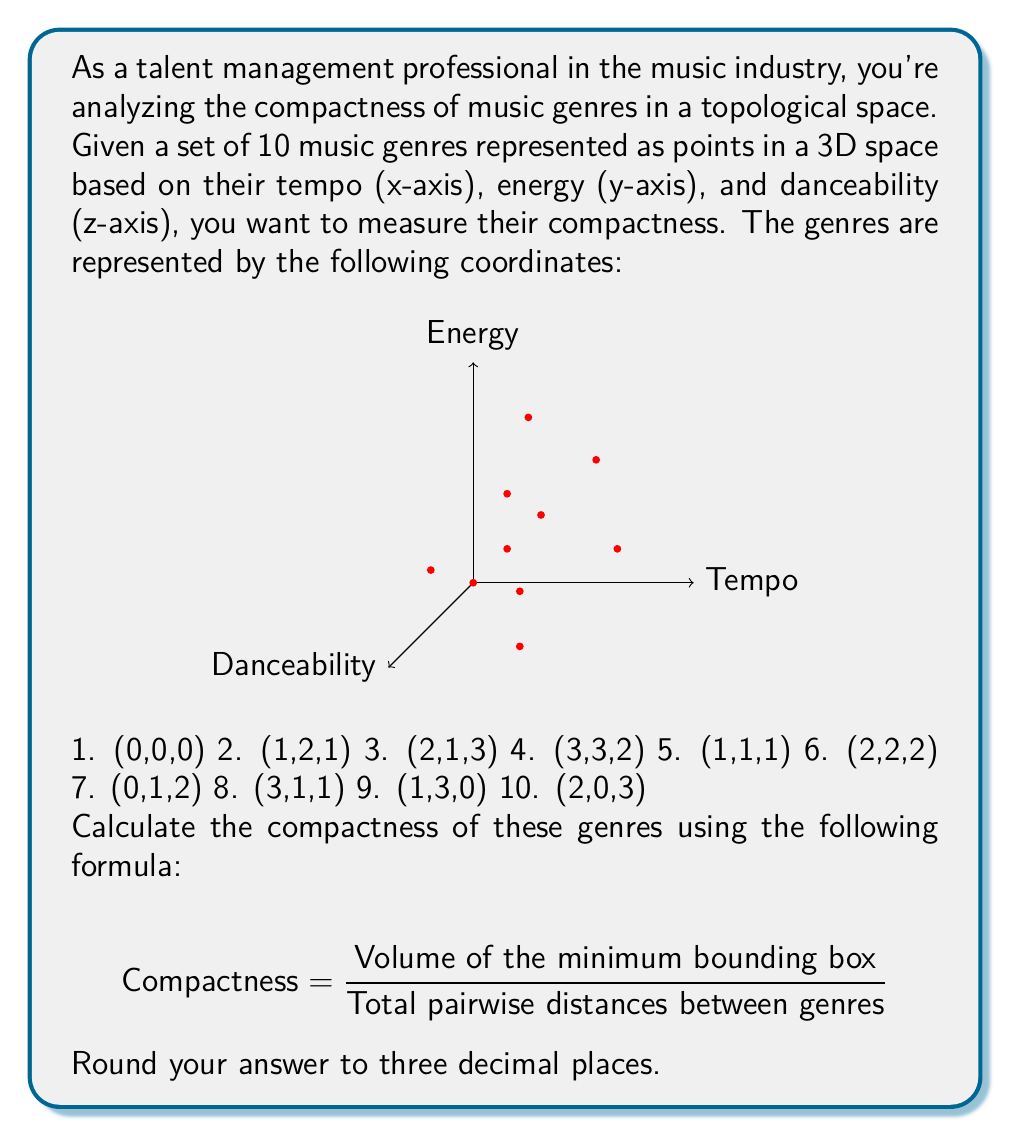Show me your answer to this math problem. To solve this problem, we'll follow these steps:

1. Find the minimum bounding box and calculate its volume.
2. Calculate the total pairwise distances between genres.
3. Apply the compactness formula.

Step 1: Minimum bounding box
- x-range: 0 to 3
- y-range: 0 to 3
- z-range: 0 to 3

Volume = $3 \times 3 \times 3 = 27$ cubic units

Step 2: Total pairwise distances
We need to calculate the Euclidean distance between each pair of genres and sum them up. The formula for Euclidean distance in 3D space is:

$$ d = \sqrt{(x_2-x_1)^2 + (y_2-y_1)^2 + (z_2-z_1)^2} $$

There are $\binom{10}{2} = 45$ pairs. Let's calculate a few:

d(1,2) = $\sqrt{(1-0)^2 + (2-0)^2 + (1-0)^2} = \sqrt{6}$
d(1,3) = $\sqrt{(2-0)^2 + (1-0)^2 + (3-0)^2} = \sqrt{14}$
...

Summing all 45 distances: 
Total distance ≈ 161.7243 units

Step 3: Apply the compactness formula

$$ \text{Compactness} = \frac{27}{161.7243} \approx 0.167 $$
Answer: 0.167 